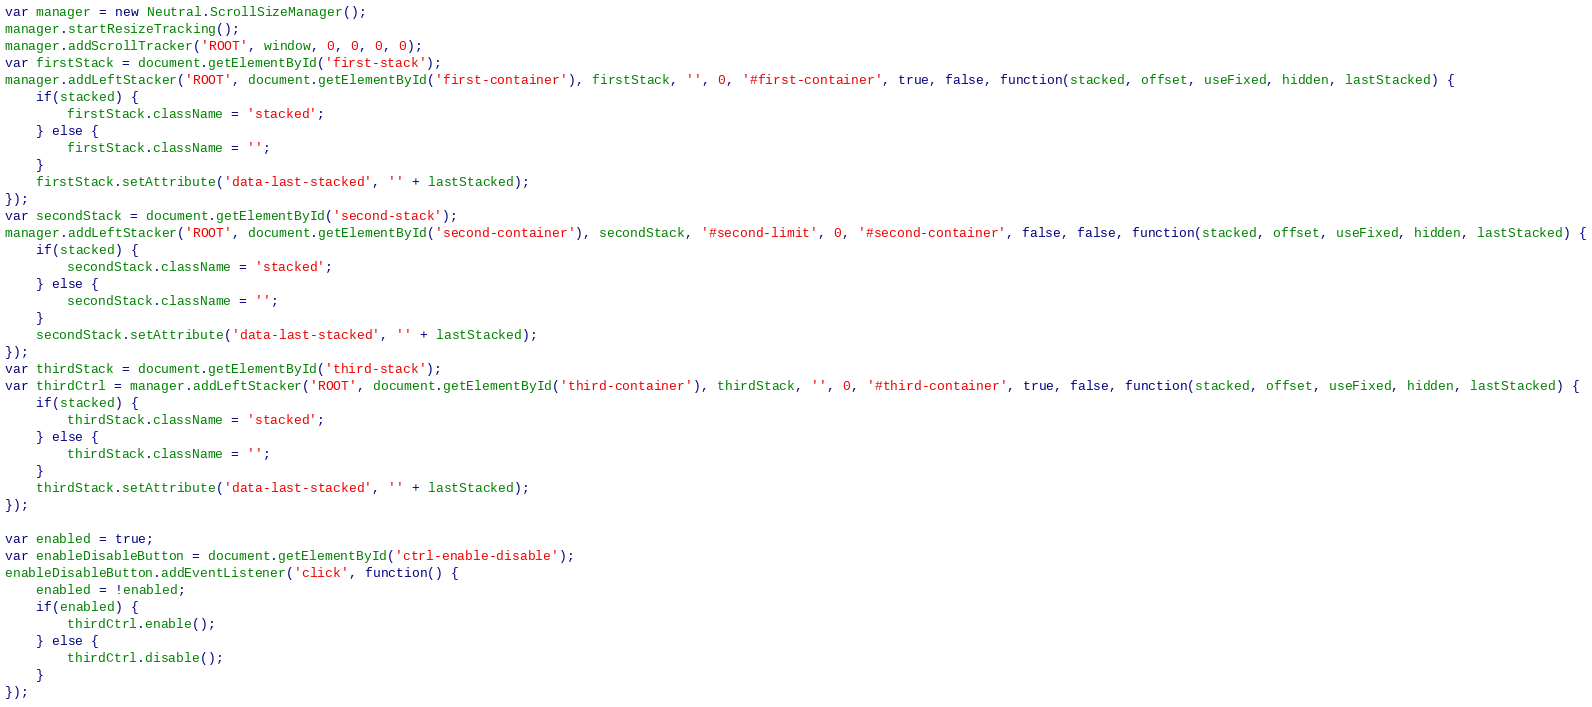Convert code to text. <code><loc_0><loc_0><loc_500><loc_500><_JavaScript_>var manager = new Neutral.ScrollSizeManager();
manager.startResizeTracking();
manager.addScrollTracker('ROOT', window, 0, 0, 0, 0);
var firstStack = document.getElementById('first-stack');
manager.addLeftStacker('ROOT', document.getElementById('first-container'), firstStack, '', 0, '#first-container', true, false, function(stacked, offset, useFixed, hidden, lastStacked) {
    if(stacked) {
        firstStack.className = 'stacked';
    } else {
        firstStack.className = '';
    }
    firstStack.setAttribute('data-last-stacked', '' + lastStacked);
});
var secondStack = document.getElementById('second-stack');
manager.addLeftStacker('ROOT', document.getElementById('second-container'), secondStack, '#second-limit', 0, '#second-container', false, false, function(stacked, offset, useFixed, hidden, lastStacked) {
    if(stacked) {
        secondStack.className = 'stacked';
    } else {
        secondStack.className = '';
    }
    secondStack.setAttribute('data-last-stacked', '' + lastStacked);
});
var thirdStack = document.getElementById('third-stack');
var thirdCtrl = manager.addLeftStacker('ROOT', document.getElementById('third-container'), thirdStack, '', 0, '#third-container', true, false, function(stacked, offset, useFixed, hidden, lastStacked) {
    if(stacked) {
        thirdStack.className = 'stacked';
    } else {
        thirdStack.className = '';
    }
    thirdStack.setAttribute('data-last-stacked', '' + lastStacked);
});

var enabled = true;
var enableDisableButton = document.getElementById('ctrl-enable-disable');
enableDisableButton.addEventListener('click', function() {
    enabled = !enabled;
    if(enabled) {
        thirdCtrl.enable();
    } else {
        thirdCtrl.disable();
    }
});
</code> 